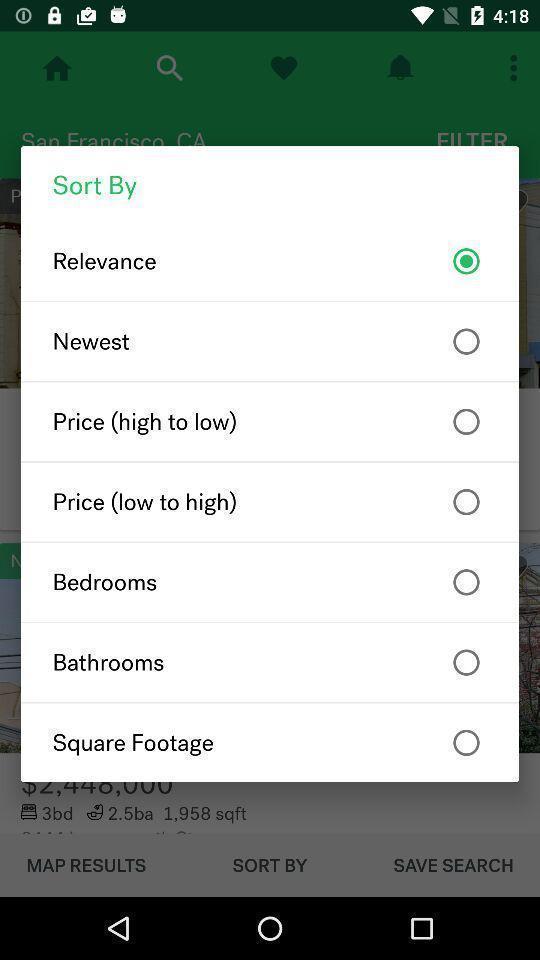What can you discern from this picture? Popup displaying list of information about finding new house application. 